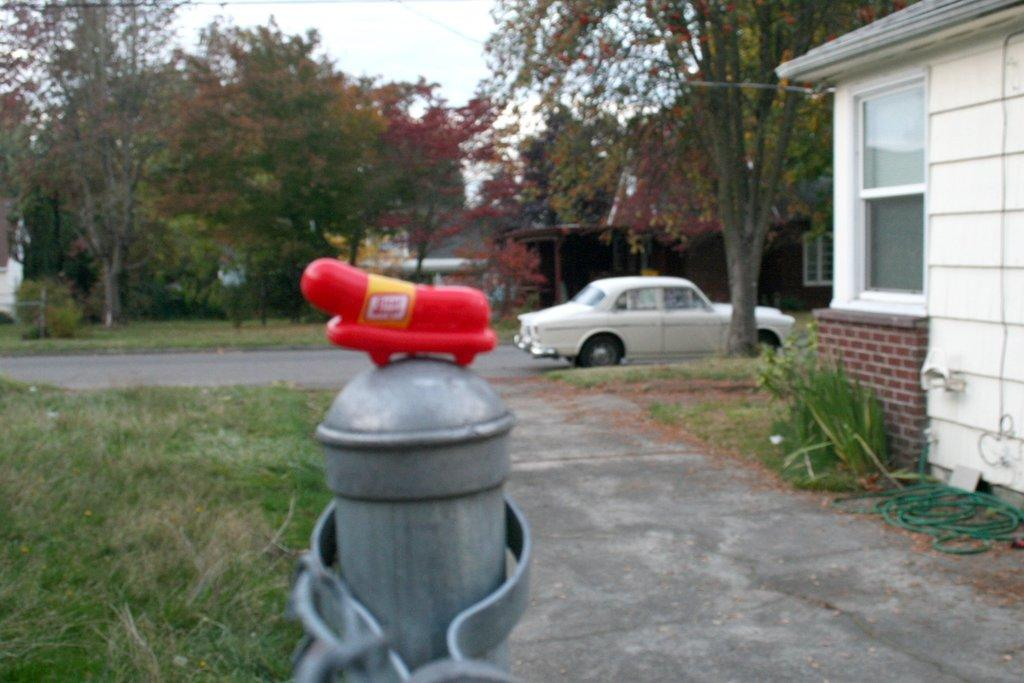What type of structures can be seen in the image? There are buildings in the image. What natural elements are present in the image? There are trees and grass in the image. What man-made object can be seen in the image? There is a car in the image. What infrastructure element is visible in the image? There is a pipeline in the image. What additional objects can be found in the image? There are shredded leaves and a pole in the image. What part of the natural environment is visible in the image? The sky is visible in the image. How many deer are visible in the image? There are no deer present in the image. What type of fold can be seen in the image? There is no fold present in the image. 